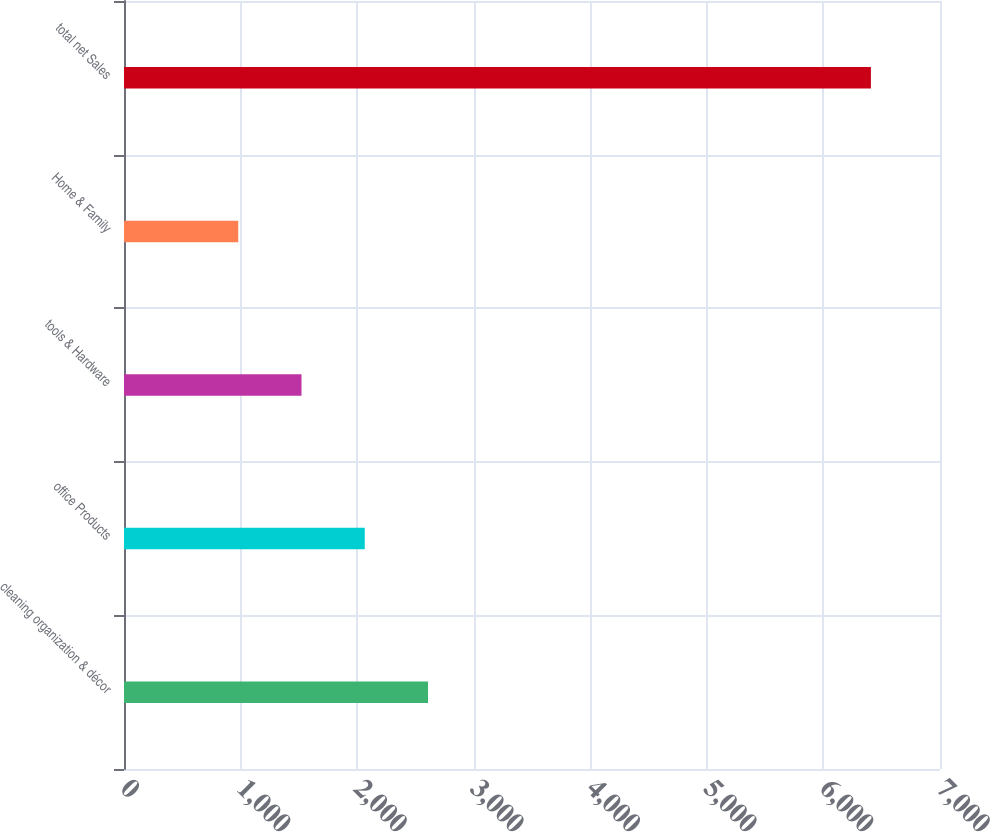<chart> <loc_0><loc_0><loc_500><loc_500><bar_chart><fcel>cleaning organization & décor<fcel>office Products<fcel>tools & Hardware<fcel>Home & Family<fcel>total net Sales<nl><fcel>2608.12<fcel>2065.38<fcel>1522.64<fcel>979.9<fcel>6407.3<nl></chart> 